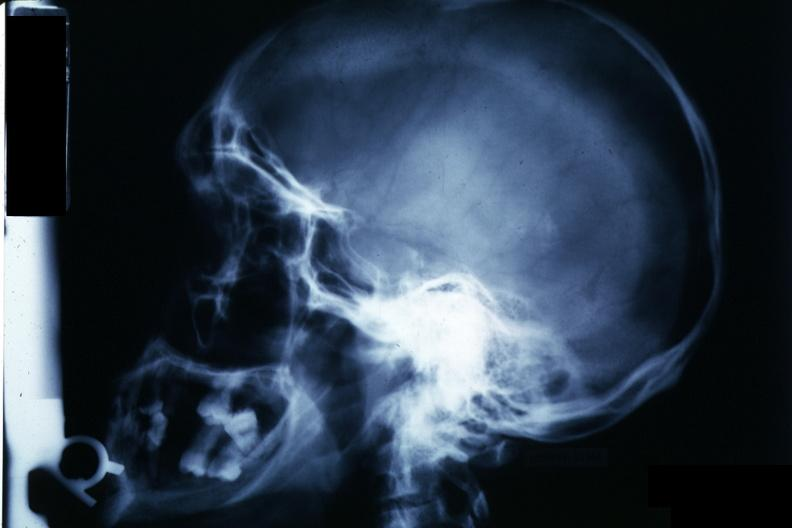what is present?
Answer the question using a single word or phrase. Pituitary 